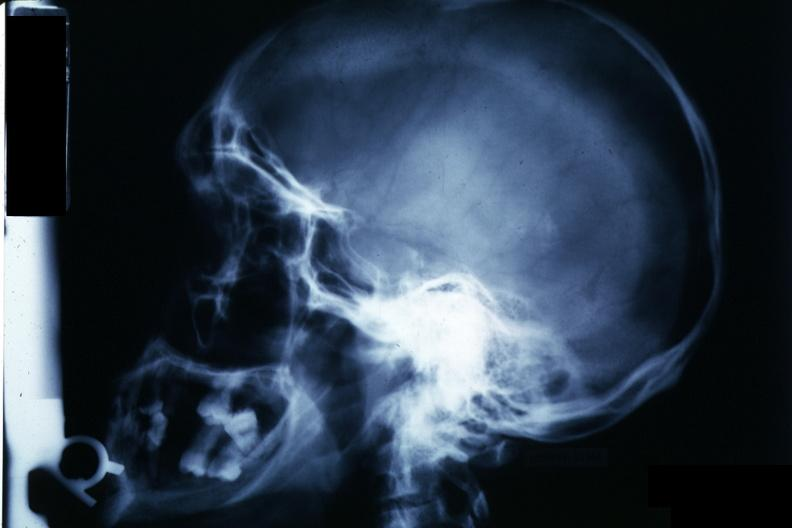what is present?
Answer the question using a single word or phrase. Pituitary 